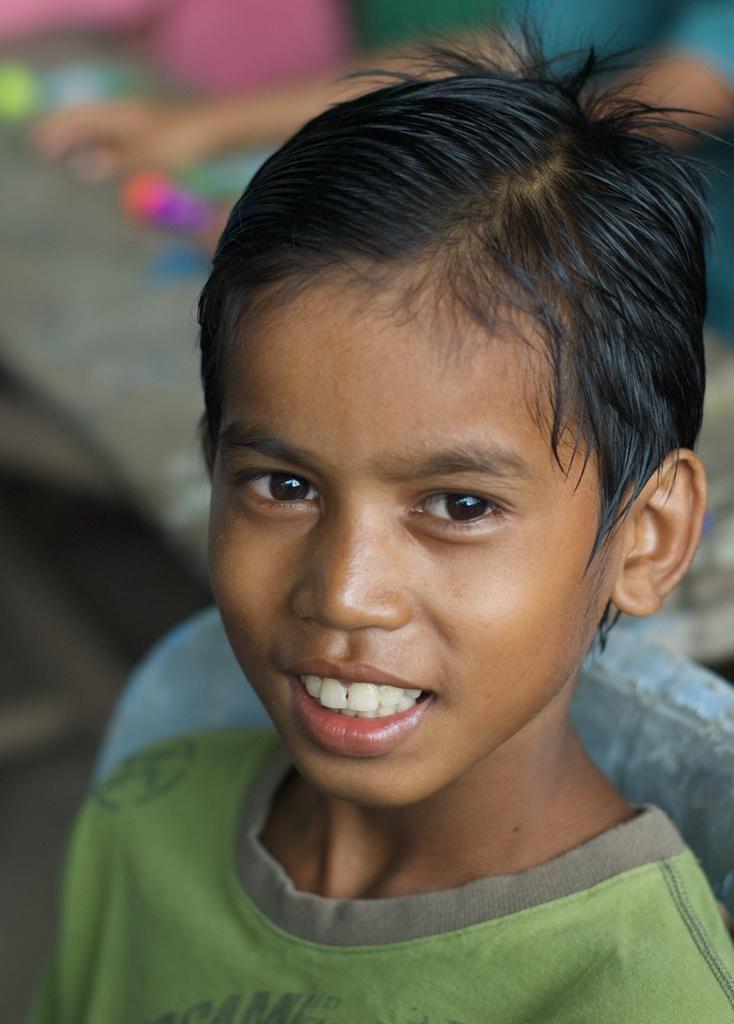How would you summarize this image in a sentence or two? As we can see in the image, there is a boy wearing green color shirt. The background is blurry. 